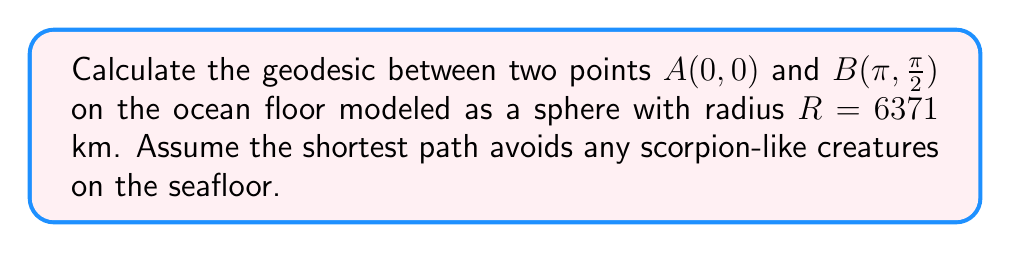Provide a solution to this math problem. Let's approach this step-by-step:

1) On a sphere, the geodesic between two points is the great circle arc connecting them. The length of this arc is given by the product of the sphere's radius and the central angle between the two points.

2) To find the central angle, we use the spherical law of cosines:

   $$\cos(c) = \sin(a)\sin(b) + \cos(a)\cos(b)\cos(C)$$

   Where a and b are the latitudes, C is the difference in longitudes, and c is the central angle we're looking for.

3) In our case:
   a = 0 (latitude of A)
   b = π/2 (latitude of B)
   C = π (difference in longitudes)

4) Substituting these values:

   $$\cos(c) = \sin(0)\sin(\frac{\pi}{2}) + \cos(0)\cos(\frac{\pi}{2})\cos(\pi)$$

5) Simplifying:
   $$\cos(c) = 0 + 1 \cdot 0 \cdot (-1) = 0$$

6) Therefore:
   $$c = \arccos(0) = \frac{\pi}{2}$$

7) The length of the geodesic is:

   $$L = R \cdot c = 6371 \cdot \frac{\pi}{2} \approx 10,007.54 \text{ km}$$

This path ensures you're always taking the shortest route while staying as far as possible from any potential scorpion-like creatures on the seafloor.
Answer: $10,007.54 \text{ km}$ 